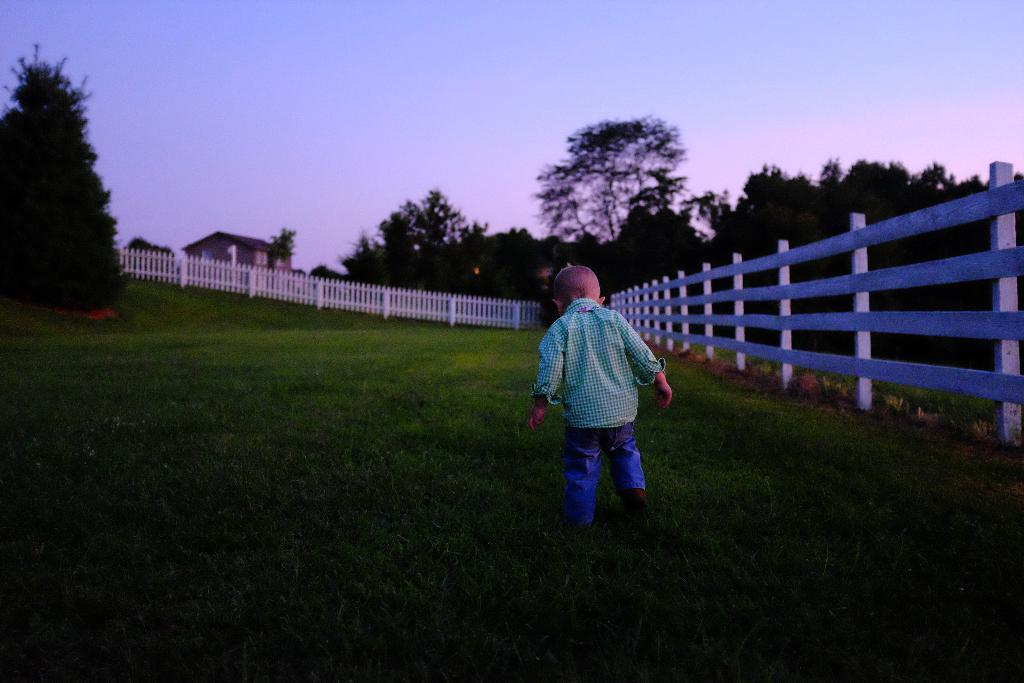What is the main subject of the image? There is a child walking in the image. What can be seen in the background of the image? There is fencing, trees, and a house in the image. What is the color of the sky in the image? The sky is white and blue in color. What type of government is depicted in the image? There is no depiction of a government in the image; it features a child walking, fencing, trees, a house, and a white and blue sky. 